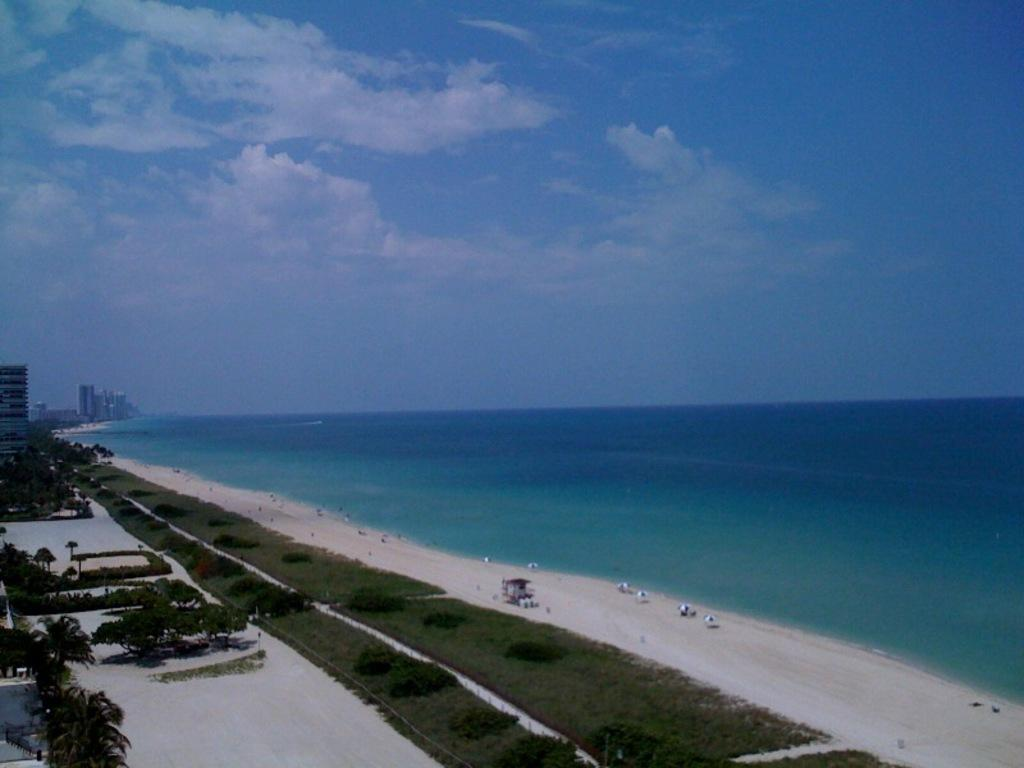What type of natural environment is on the right side of the image? There is a beach on the right side of the image. What type of natural environment is on the left side of the image? There is a garden on the left side of the image. What type of vegetation can be seen in the left side of the image? There are trees in the left side of the image. What structures can be seen in the background of the image? There are buildings visible in the background of the image. What is visible at the top of the image? The sky is visible at the top of the image. What can be seen in the sky? Clouds are present in the sky. How many chickens are running around in the garden on the left side of the image? There are no chickens present in the image. What type of seed is being used to grow the plants in the garden on the left side of the image? There is no information about the type of seed used in the garden; only trees are mentioned. What color is the scarf that the person on the beach is wearing? There are no people or scarves present in the image. 